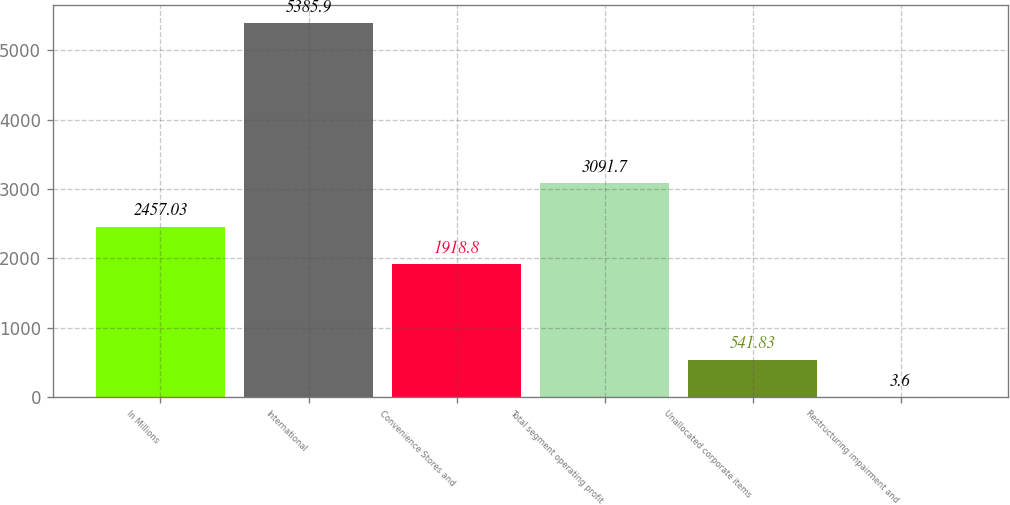<chart> <loc_0><loc_0><loc_500><loc_500><bar_chart><fcel>In Millions<fcel>International<fcel>Convenience Stores and<fcel>Total segment operating profit<fcel>Unallocated corporate items<fcel>Restructuring impairment and<nl><fcel>2457.03<fcel>5385.9<fcel>1918.8<fcel>3091.7<fcel>541.83<fcel>3.6<nl></chart> 